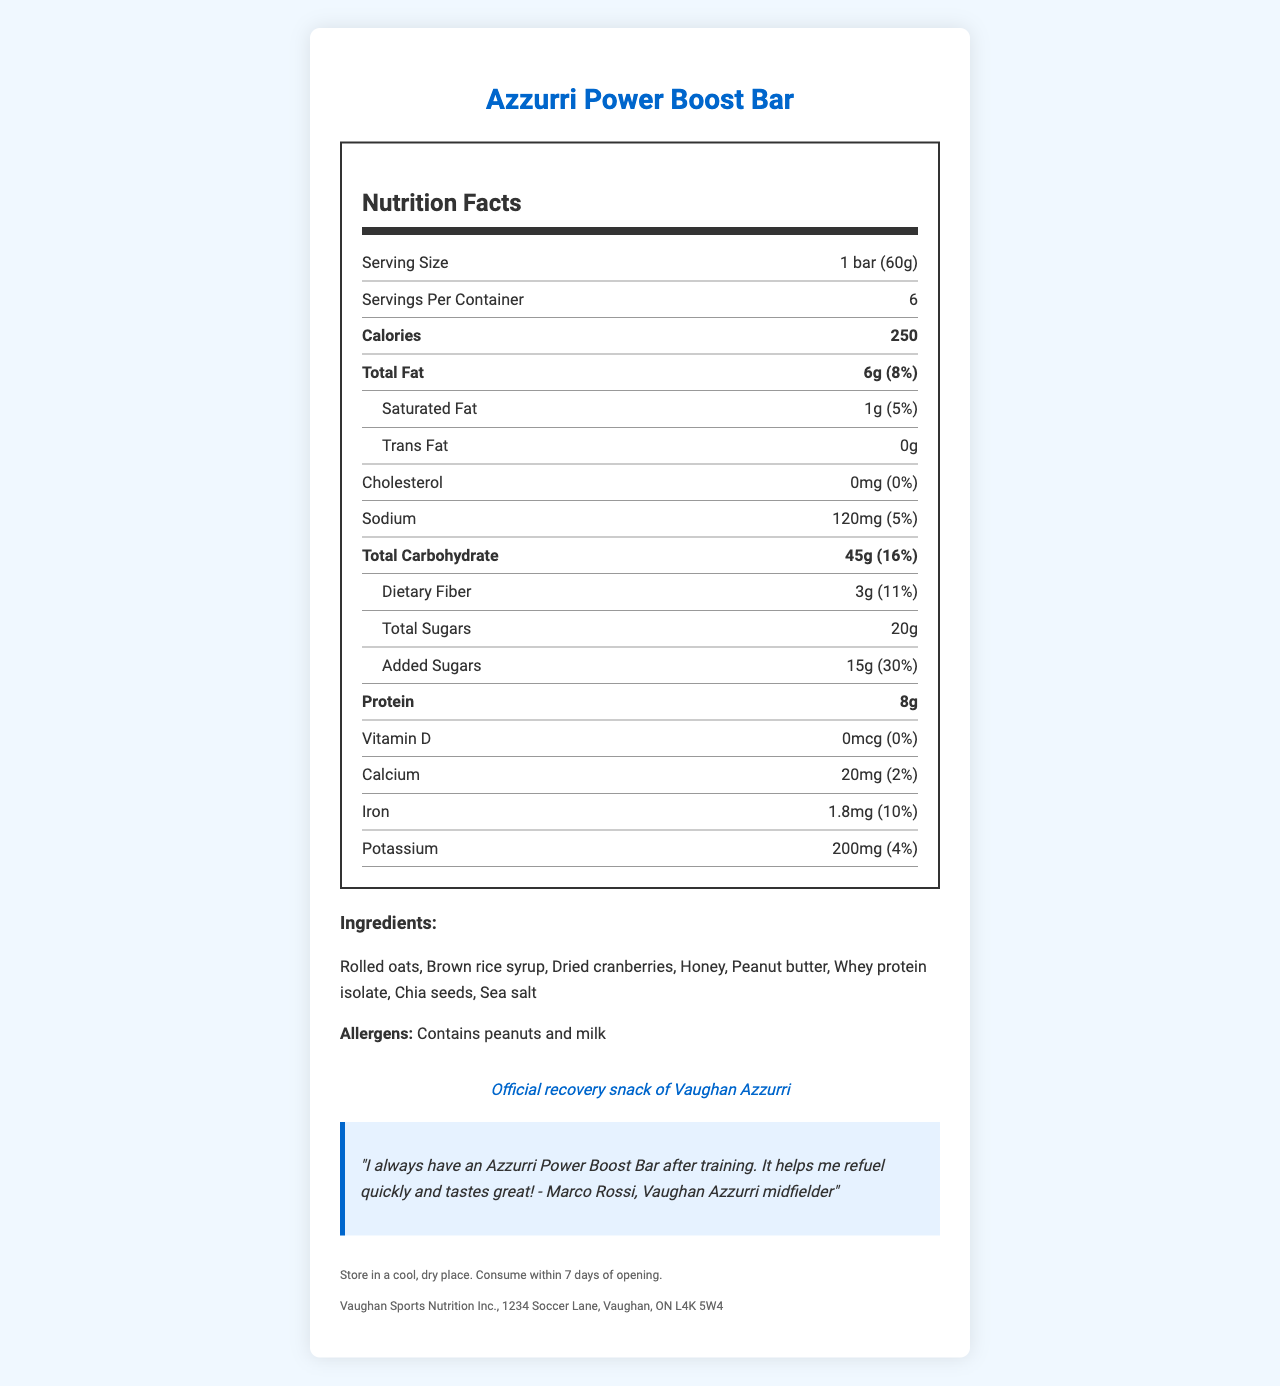what is the product name? The product name is clearly stated at the top of the document.
Answer: Azzurri Power Boost Bar how many calories does one serving contain? The document lists that one serving contains 250 calories.
Answer: 250 how much protein is in one serving of the bar? The document specifies that there are 8 grams of protein in one serving.
Answer: 8g what are the main ingredients of the Azzurri Power Boost Bar? The ingredients are listed in the ingredients section of the document.
Answer: Rolled oats, Brown rice syrup, Dried cranberries, Honey, Peanut butter, Whey protein isolate, Chia seeds, Sea salt how much sodium does one serving of the bar contain? The document states that one serving contains 120 milligrams of sodium.
Answer: 120mg what is the manufacturer of the Azzurri Power Boost Bar? The manufacturer is listed in the footer of the document.
Answer: Vaughan Sports Nutrition Inc. how long should you consume the bar after opening? The storage instructions in the footer state that the bar should be consumed within 7 days of opening.
Answer: Within 7 days what is the daily value percentage of added sugars in one serving? The document specifies that one serving of the bar contains 30% of the daily value of added sugars.
Answer: 30% **Multiple-choice:**
how much dietary fiber does one serving of the bar contain?
A) 2g
B) 3g
C) 5g
D) 8g The document lists that one serving has 3 grams of dietary fiber.
Answer: B how many servings are in one container of the Azzurri Power Boost Bar?
1) 4
2) 5
3) 6
4) 8 The document states that there are 6 servings per container.
Answer: 3 **Yes/No:**
does the bar contain any cholesterol? The document states that the bar contains 0mg of cholesterol, which equates to 0% daily value.
Answer: No **Summary:**
what is the main idea of this document? The document details all necessary nutritional information and endorsements for the Azzurri Power Boost Bar.
Answer: The main idea is to provide nutrition facts about the Azzurri Power Boost Bar, including serving size, calories, macronutrients, vitamins, minerals, ingredients, allergens, storage instructions, and endorsements by Vaughan Azzurri players. **Unanswerable:**
what is the exact cost of one container of the Azzurri Power Boost Bar? The document does not provide any information regarding the price of the container.
Answer: Not enough information 